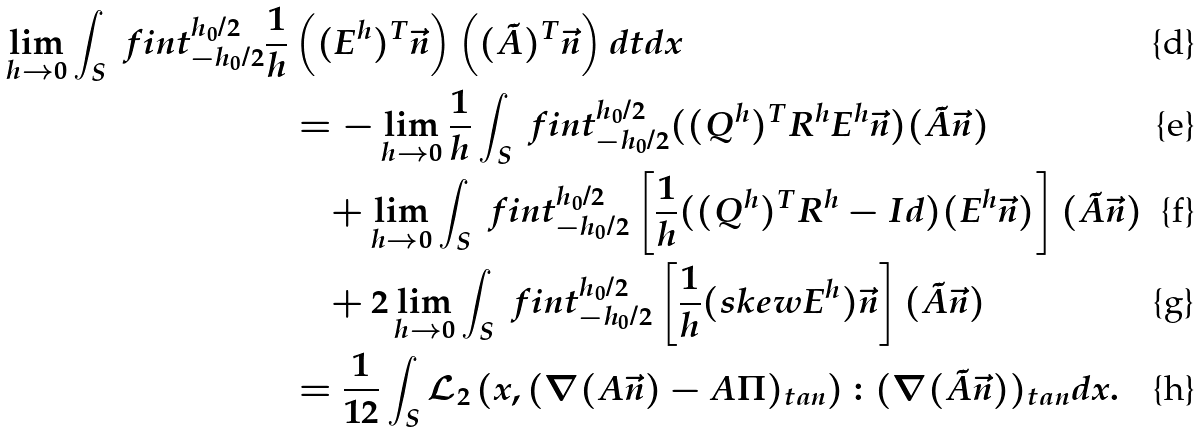Convert formula to latex. <formula><loc_0><loc_0><loc_500><loc_500>\lim _ { h \to 0 } \int _ { S } \ f i n t _ { - h _ { 0 } / 2 } ^ { h _ { 0 } / 2 } \frac { 1 } { h } & \left ( ( E ^ { h } ) ^ { T } \vec { n } \right ) \left ( ( \tilde { A } ) ^ { T } \vec { n } \right ) d t d x \\ & = - \lim _ { h \to 0 } \frac { 1 } { h } \int _ { S } \ f i n t _ { - h _ { 0 } / 2 } ^ { h _ { 0 } / 2 } ( ( Q ^ { h } ) ^ { T } R ^ { h } E ^ { h } \vec { n } ) ( \tilde { A } \vec { n } ) \\ & \quad + \lim _ { h \to 0 } \int _ { S } \ f i n t _ { - h _ { 0 } / 2 } ^ { h _ { 0 } / 2 } \left [ \frac { 1 } { h } ( ( Q ^ { h } ) ^ { T } R ^ { h } - I d ) ( E ^ { h } \vec { n } ) \right ] ( \tilde { A } \vec { n } ) \\ & \quad + 2 \lim _ { h \to 0 } \int _ { S } \ f i n t _ { - h _ { 0 } / 2 } ^ { h _ { 0 } / 2 } \left [ \frac { 1 } { h } ( s k e w E ^ { h } ) \vec { n } \right ] ( \tilde { A } \vec { n } ) \\ & = \frac { 1 } { 1 2 } \int _ { S } \mathcal { L } _ { 2 } \left ( x , ( \nabla ( A \vec { n } ) - A \Pi ) _ { t a n } \right ) \colon ( \nabla ( \tilde { A } \vec { n } ) ) _ { t a n } d x .</formula> 